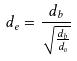<formula> <loc_0><loc_0><loc_500><loc_500>d _ { e } = \frac { d _ { b } } { \sqrt { \frac { d _ { b } } { d _ { v } } } }</formula> 